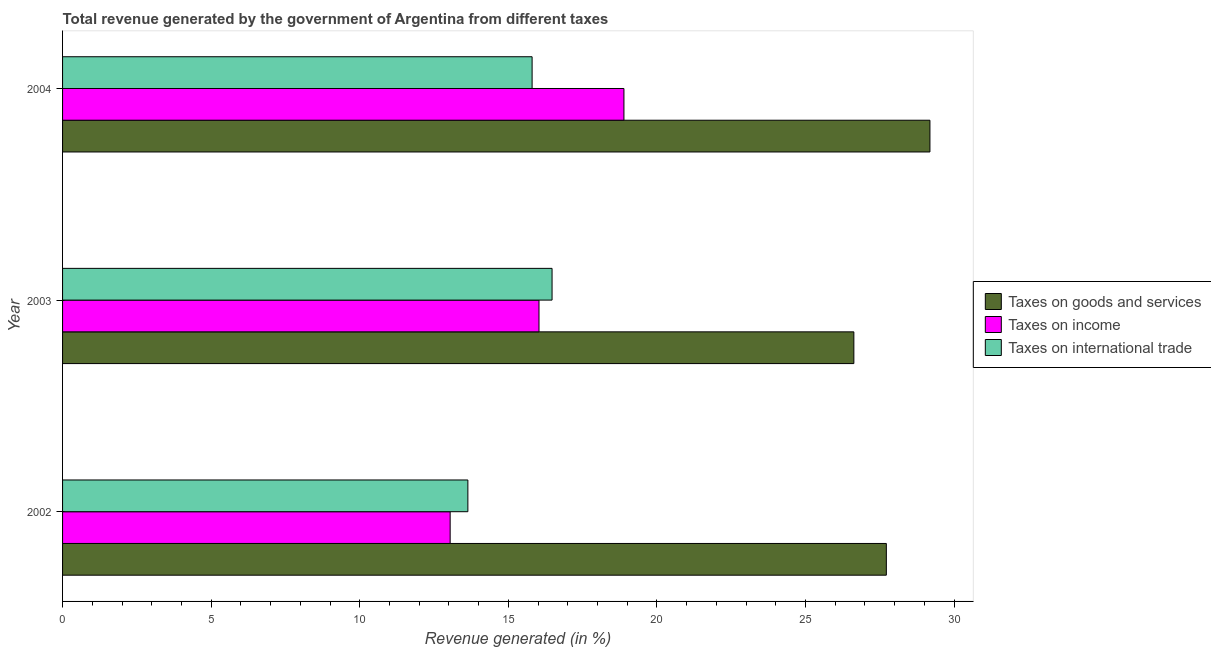Are the number of bars on each tick of the Y-axis equal?
Your answer should be very brief. Yes. How many bars are there on the 3rd tick from the top?
Ensure brevity in your answer.  3. What is the label of the 3rd group of bars from the top?
Keep it short and to the point. 2002. In how many cases, is the number of bars for a given year not equal to the number of legend labels?
Make the answer very short. 0. What is the percentage of revenue generated by taxes on goods and services in 2003?
Your response must be concise. 26.63. Across all years, what is the maximum percentage of revenue generated by taxes on goods and services?
Give a very brief answer. 29.19. Across all years, what is the minimum percentage of revenue generated by tax on international trade?
Offer a very short reply. 13.64. What is the total percentage of revenue generated by taxes on goods and services in the graph?
Keep it short and to the point. 83.53. What is the difference between the percentage of revenue generated by taxes on income in 2002 and that in 2004?
Provide a succinct answer. -5.85. What is the difference between the percentage of revenue generated by tax on international trade in 2002 and the percentage of revenue generated by taxes on income in 2004?
Your answer should be compact. -5.25. What is the average percentage of revenue generated by taxes on income per year?
Your answer should be very brief. 15.99. In the year 2004, what is the difference between the percentage of revenue generated by taxes on goods and services and percentage of revenue generated by taxes on income?
Ensure brevity in your answer.  10.3. What is the ratio of the percentage of revenue generated by tax on international trade in 2003 to that in 2004?
Give a very brief answer. 1.04. What is the difference between the highest and the second highest percentage of revenue generated by tax on international trade?
Offer a very short reply. 0.67. What is the difference between the highest and the lowest percentage of revenue generated by tax on international trade?
Provide a short and direct response. 2.83. In how many years, is the percentage of revenue generated by tax on international trade greater than the average percentage of revenue generated by tax on international trade taken over all years?
Keep it short and to the point. 2. What does the 3rd bar from the top in 2002 represents?
Give a very brief answer. Taxes on goods and services. What does the 2nd bar from the bottom in 2002 represents?
Your answer should be compact. Taxes on income. Is it the case that in every year, the sum of the percentage of revenue generated by taxes on goods and services and percentage of revenue generated by taxes on income is greater than the percentage of revenue generated by tax on international trade?
Provide a short and direct response. Yes. How many bars are there?
Your answer should be compact. 9. Are all the bars in the graph horizontal?
Offer a terse response. Yes. What is the difference between two consecutive major ticks on the X-axis?
Make the answer very short. 5. Are the values on the major ticks of X-axis written in scientific E-notation?
Make the answer very short. No. Does the graph contain any zero values?
Provide a short and direct response. No. Does the graph contain grids?
Provide a short and direct response. No. Where does the legend appear in the graph?
Make the answer very short. Center right. How many legend labels are there?
Make the answer very short. 3. What is the title of the graph?
Provide a succinct answer. Total revenue generated by the government of Argentina from different taxes. What is the label or title of the X-axis?
Your answer should be very brief. Revenue generated (in %). What is the Revenue generated (in %) in Taxes on goods and services in 2002?
Offer a very short reply. 27.72. What is the Revenue generated (in %) in Taxes on income in 2002?
Provide a succinct answer. 13.04. What is the Revenue generated (in %) in Taxes on international trade in 2002?
Offer a terse response. 13.64. What is the Revenue generated (in %) in Taxes on goods and services in 2003?
Your response must be concise. 26.63. What is the Revenue generated (in %) of Taxes on income in 2003?
Make the answer very short. 16.03. What is the Revenue generated (in %) in Taxes on international trade in 2003?
Ensure brevity in your answer.  16.47. What is the Revenue generated (in %) of Taxes on goods and services in 2004?
Offer a very short reply. 29.19. What is the Revenue generated (in %) of Taxes on income in 2004?
Offer a terse response. 18.89. What is the Revenue generated (in %) in Taxes on international trade in 2004?
Give a very brief answer. 15.8. Across all years, what is the maximum Revenue generated (in %) in Taxes on goods and services?
Make the answer very short. 29.19. Across all years, what is the maximum Revenue generated (in %) in Taxes on income?
Offer a terse response. 18.89. Across all years, what is the maximum Revenue generated (in %) of Taxes on international trade?
Your answer should be very brief. 16.47. Across all years, what is the minimum Revenue generated (in %) in Taxes on goods and services?
Make the answer very short. 26.63. Across all years, what is the minimum Revenue generated (in %) of Taxes on income?
Ensure brevity in your answer.  13.04. Across all years, what is the minimum Revenue generated (in %) of Taxes on international trade?
Keep it short and to the point. 13.64. What is the total Revenue generated (in %) of Taxes on goods and services in the graph?
Provide a short and direct response. 83.53. What is the total Revenue generated (in %) of Taxes on income in the graph?
Your answer should be very brief. 47.96. What is the total Revenue generated (in %) in Taxes on international trade in the graph?
Provide a succinct answer. 45.91. What is the difference between the Revenue generated (in %) in Taxes on goods and services in 2002 and that in 2003?
Your answer should be very brief. 1.09. What is the difference between the Revenue generated (in %) in Taxes on income in 2002 and that in 2003?
Your answer should be very brief. -2.99. What is the difference between the Revenue generated (in %) of Taxes on international trade in 2002 and that in 2003?
Make the answer very short. -2.83. What is the difference between the Revenue generated (in %) of Taxes on goods and services in 2002 and that in 2004?
Your answer should be compact. -1.47. What is the difference between the Revenue generated (in %) in Taxes on income in 2002 and that in 2004?
Ensure brevity in your answer.  -5.85. What is the difference between the Revenue generated (in %) of Taxes on international trade in 2002 and that in 2004?
Your response must be concise. -2.16. What is the difference between the Revenue generated (in %) of Taxes on goods and services in 2003 and that in 2004?
Provide a short and direct response. -2.56. What is the difference between the Revenue generated (in %) in Taxes on income in 2003 and that in 2004?
Ensure brevity in your answer.  -2.86. What is the difference between the Revenue generated (in %) in Taxes on international trade in 2003 and that in 2004?
Provide a succinct answer. 0.67. What is the difference between the Revenue generated (in %) of Taxes on goods and services in 2002 and the Revenue generated (in %) of Taxes on income in 2003?
Your response must be concise. 11.69. What is the difference between the Revenue generated (in %) in Taxes on goods and services in 2002 and the Revenue generated (in %) in Taxes on international trade in 2003?
Keep it short and to the point. 11.25. What is the difference between the Revenue generated (in %) of Taxes on income in 2002 and the Revenue generated (in %) of Taxes on international trade in 2003?
Provide a short and direct response. -3.43. What is the difference between the Revenue generated (in %) of Taxes on goods and services in 2002 and the Revenue generated (in %) of Taxes on income in 2004?
Give a very brief answer. 8.83. What is the difference between the Revenue generated (in %) in Taxes on goods and services in 2002 and the Revenue generated (in %) in Taxes on international trade in 2004?
Offer a very short reply. 11.92. What is the difference between the Revenue generated (in %) in Taxes on income in 2002 and the Revenue generated (in %) in Taxes on international trade in 2004?
Ensure brevity in your answer.  -2.76. What is the difference between the Revenue generated (in %) in Taxes on goods and services in 2003 and the Revenue generated (in %) in Taxes on income in 2004?
Your answer should be very brief. 7.74. What is the difference between the Revenue generated (in %) of Taxes on goods and services in 2003 and the Revenue generated (in %) of Taxes on international trade in 2004?
Provide a short and direct response. 10.83. What is the difference between the Revenue generated (in %) of Taxes on income in 2003 and the Revenue generated (in %) of Taxes on international trade in 2004?
Your answer should be compact. 0.23. What is the average Revenue generated (in %) in Taxes on goods and services per year?
Your answer should be compact. 27.84. What is the average Revenue generated (in %) in Taxes on income per year?
Keep it short and to the point. 15.99. What is the average Revenue generated (in %) in Taxes on international trade per year?
Keep it short and to the point. 15.3. In the year 2002, what is the difference between the Revenue generated (in %) in Taxes on goods and services and Revenue generated (in %) in Taxes on income?
Keep it short and to the point. 14.68. In the year 2002, what is the difference between the Revenue generated (in %) of Taxes on goods and services and Revenue generated (in %) of Taxes on international trade?
Your answer should be very brief. 14.08. In the year 2002, what is the difference between the Revenue generated (in %) of Taxes on income and Revenue generated (in %) of Taxes on international trade?
Ensure brevity in your answer.  -0.6. In the year 2003, what is the difference between the Revenue generated (in %) in Taxes on goods and services and Revenue generated (in %) in Taxes on income?
Your answer should be compact. 10.59. In the year 2003, what is the difference between the Revenue generated (in %) of Taxes on goods and services and Revenue generated (in %) of Taxes on international trade?
Give a very brief answer. 10.16. In the year 2003, what is the difference between the Revenue generated (in %) of Taxes on income and Revenue generated (in %) of Taxes on international trade?
Your response must be concise. -0.44. In the year 2004, what is the difference between the Revenue generated (in %) in Taxes on goods and services and Revenue generated (in %) in Taxes on income?
Ensure brevity in your answer.  10.3. In the year 2004, what is the difference between the Revenue generated (in %) in Taxes on goods and services and Revenue generated (in %) in Taxes on international trade?
Your response must be concise. 13.39. In the year 2004, what is the difference between the Revenue generated (in %) in Taxes on income and Revenue generated (in %) in Taxes on international trade?
Offer a very short reply. 3.09. What is the ratio of the Revenue generated (in %) in Taxes on goods and services in 2002 to that in 2003?
Provide a succinct answer. 1.04. What is the ratio of the Revenue generated (in %) in Taxes on income in 2002 to that in 2003?
Keep it short and to the point. 0.81. What is the ratio of the Revenue generated (in %) in Taxes on international trade in 2002 to that in 2003?
Offer a terse response. 0.83. What is the ratio of the Revenue generated (in %) of Taxes on goods and services in 2002 to that in 2004?
Provide a short and direct response. 0.95. What is the ratio of the Revenue generated (in %) of Taxes on income in 2002 to that in 2004?
Keep it short and to the point. 0.69. What is the ratio of the Revenue generated (in %) in Taxes on international trade in 2002 to that in 2004?
Provide a short and direct response. 0.86. What is the ratio of the Revenue generated (in %) of Taxes on goods and services in 2003 to that in 2004?
Offer a terse response. 0.91. What is the ratio of the Revenue generated (in %) of Taxes on income in 2003 to that in 2004?
Your answer should be very brief. 0.85. What is the ratio of the Revenue generated (in %) in Taxes on international trade in 2003 to that in 2004?
Your response must be concise. 1.04. What is the difference between the highest and the second highest Revenue generated (in %) in Taxes on goods and services?
Make the answer very short. 1.47. What is the difference between the highest and the second highest Revenue generated (in %) of Taxes on income?
Provide a succinct answer. 2.86. What is the difference between the highest and the second highest Revenue generated (in %) of Taxes on international trade?
Your answer should be very brief. 0.67. What is the difference between the highest and the lowest Revenue generated (in %) in Taxes on goods and services?
Give a very brief answer. 2.56. What is the difference between the highest and the lowest Revenue generated (in %) of Taxes on income?
Make the answer very short. 5.85. What is the difference between the highest and the lowest Revenue generated (in %) of Taxes on international trade?
Ensure brevity in your answer.  2.83. 